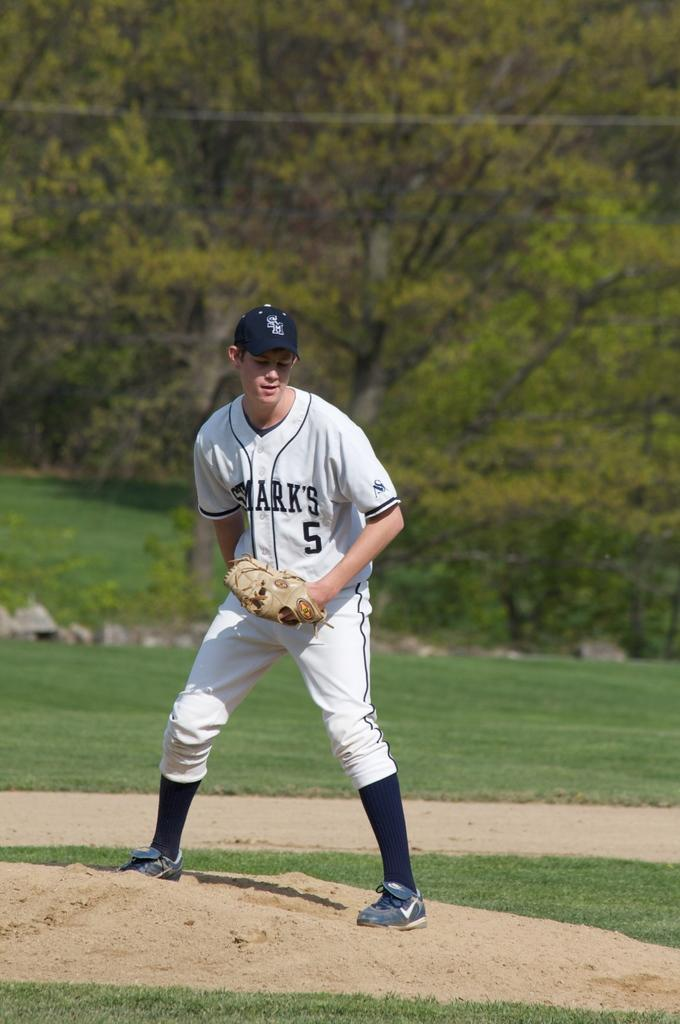Who is present in the image? There is a man in the image. What is the man wearing? The man is wearing a white dress and a cap. What is the man's position in the image? The man is standing on the ground. What can be seen in the background of the image? There are trees in the background of the image. What type of bait is the man using to catch fish in the image? There is no indication of fishing or bait in the image; the man is simply standing on the ground wearing a white dress and a cap. 